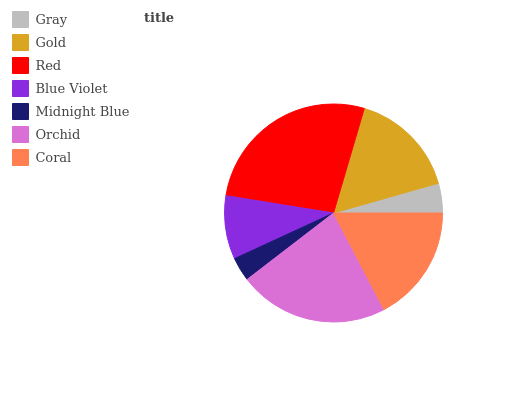Is Midnight Blue the minimum?
Answer yes or no. Yes. Is Red the maximum?
Answer yes or no. Yes. Is Gold the minimum?
Answer yes or no. No. Is Gold the maximum?
Answer yes or no. No. Is Gold greater than Gray?
Answer yes or no. Yes. Is Gray less than Gold?
Answer yes or no. Yes. Is Gray greater than Gold?
Answer yes or no. No. Is Gold less than Gray?
Answer yes or no. No. Is Gold the high median?
Answer yes or no. Yes. Is Gold the low median?
Answer yes or no. Yes. Is Gray the high median?
Answer yes or no. No. Is Blue Violet the low median?
Answer yes or no. No. 